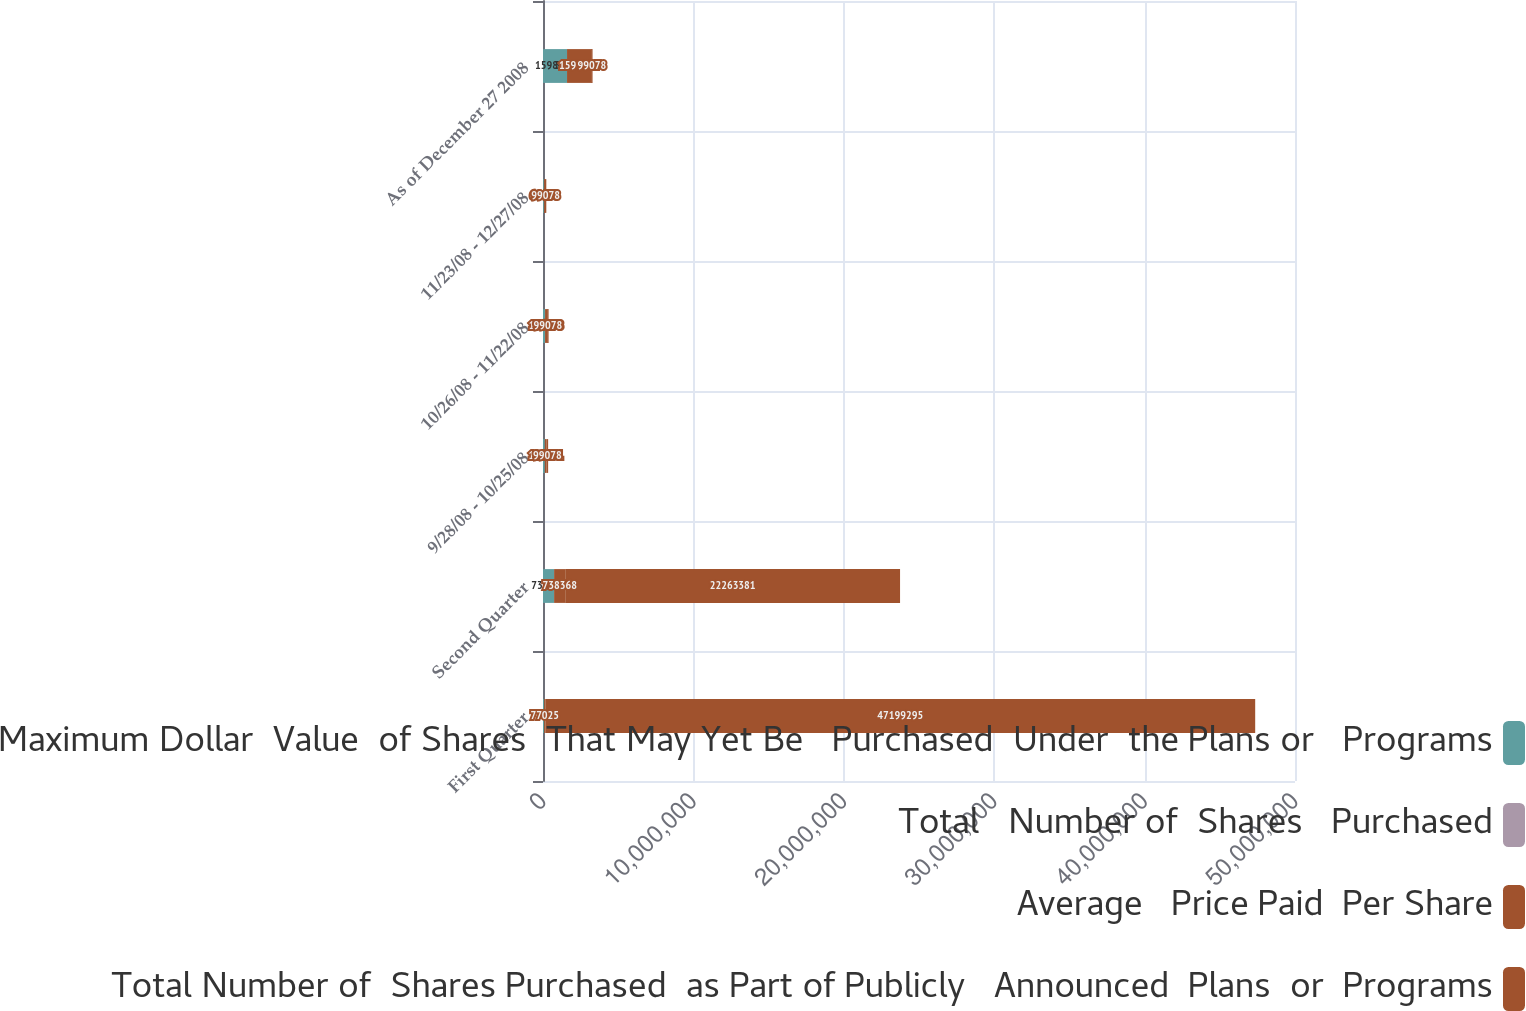Convert chart. <chart><loc_0><loc_0><loc_500><loc_500><stacked_bar_chart><ecel><fcel>First Quarter<fcel>Second Quarter<fcel>9/28/08 - 10/25/08<fcel>10/26/08 - 11/22/08<fcel>11/23/08 - 12/27/08<fcel>As of December 27 2008<nl><fcel>Maximum Dollar  Value  of Shares  That May Yet Be   Purchased  Under  the Plans or   Programs<fcel>77025<fcel>738368<fcel>121131<fcel>136378<fcel>60400<fcel>1.59811e+06<nl><fcel>Total   Number of  Shares   Purchased<fcel>37<fcel>33.8<fcel>36.12<fcel>35.35<fcel>35.93<fcel>33.71<nl><fcel>Average   Price Paid  Per Share<fcel>77025<fcel>738368<fcel>121131<fcel>136378<fcel>60400<fcel>1.59811e+06<nl><fcel>Total Number of  Shares Purchased  as Part of Publicly   Announced  Plans  or  Programs<fcel>4.71993e+07<fcel>2.22634e+07<fcel>99078<fcel>99078<fcel>99078<fcel>99078<nl></chart> 